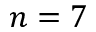<formula> <loc_0><loc_0><loc_500><loc_500>n = 7</formula> 